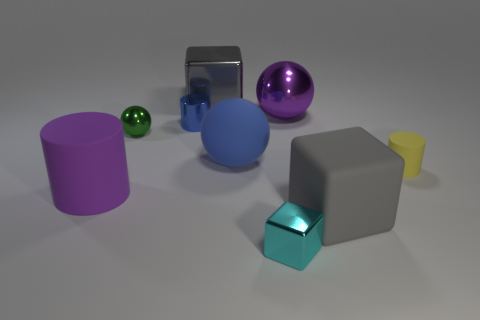Can you describe the objects in the image based on their shapes? Certainly! There's a purple cylinder, a green small sphere, a large blue sphere, a reflective cube, a transparent purple large sphere, a gray cube, a small turquoise cube, and a small yellow cone. 